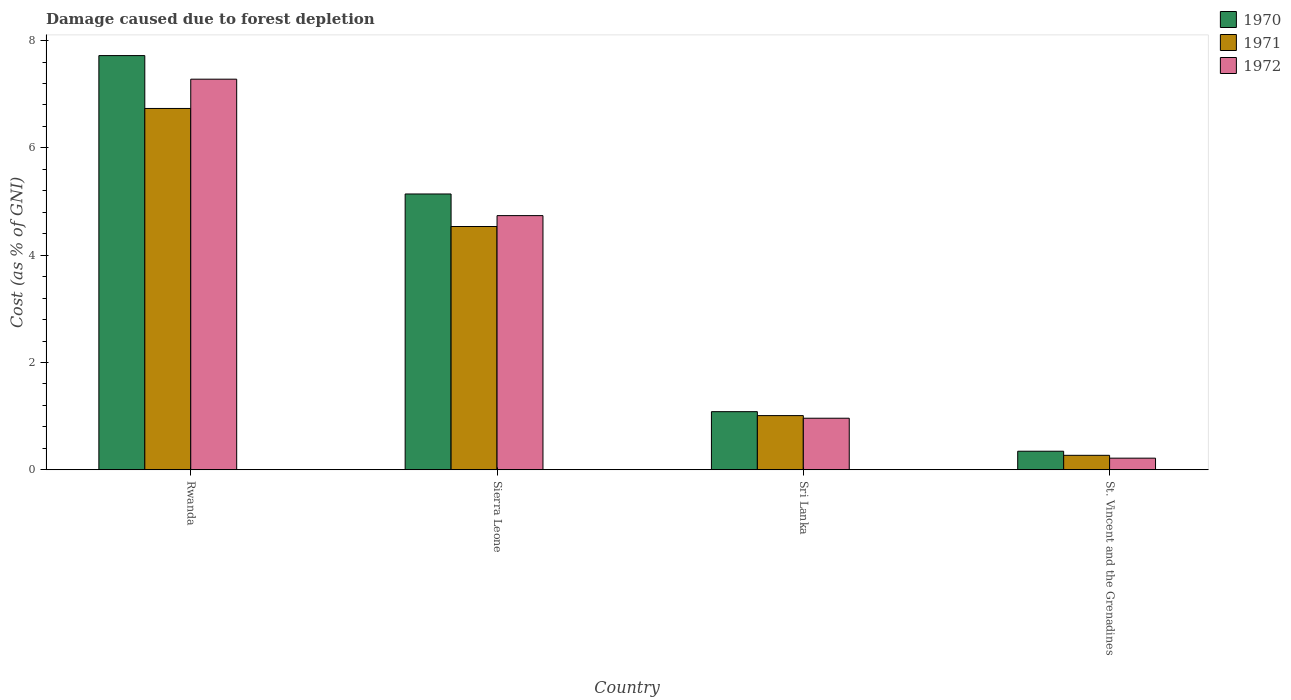How many different coloured bars are there?
Offer a terse response. 3. What is the label of the 4th group of bars from the left?
Your answer should be compact. St. Vincent and the Grenadines. In how many cases, is the number of bars for a given country not equal to the number of legend labels?
Offer a very short reply. 0. What is the cost of damage caused due to forest depletion in 1971 in Sierra Leone?
Make the answer very short. 4.53. Across all countries, what is the maximum cost of damage caused due to forest depletion in 1970?
Give a very brief answer. 7.72. Across all countries, what is the minimum cost of damage caused due to forest depletion in 1971?
Give a very brief answer. 0.27. In which country was the cost of damage caused due to forest depletion in 1972 maximum?
Your response must be concise. Rwanda. In which country was the cost of damage caused due to forest depletion in 1972 minimum?
Offer a terse response. St. Vincent and the Grenadines. What is the total cost of damage caused due to forest depletion in 1970 in the graph?
Offer a terse response. 14.29. What is the difference between the cost of damage caused due to forest depletion in 1971 in Rwanda and that in Sierra Leone?
Provide a short and direct response. 2.2. What is the difference between the cost of damage caused due to forest depletion in 1972 in Sierra Leone and the cost of damage caused due to forest depletion in 1970 in Sri Lanka?
Provide a succinct answer. 3.65. What is the average cost of damage caused due to forest depletion in 1972 per country?
Your answer should be compact. 3.3. What is the difference between the cost of damage caused due to forest depletion of/in 1970 and cost of damage caused due to forest depletion of/in 1972 in Rwanda?
Your response must be concise. 0.44. In how many countries, is the cost of damage caused due to forest depletion in 1971 greater than 2.4 %?
Your answer should be compact. 2. What is the ratio of the cost of damage caused due to forest depletion in 1972 in Rwanda to that in St. Vincent and the Grenadines?
Offer a very short reply. 33.57. Is the cost of damage caused due to forest depletion in 1972 in Rwanda less than that in Sri Lanka?
Your answer should be compact. No. What is the difference between the highest and the second highest cost of damage caused due to forest depletion in 1972?
Keep it short and to the point. -3.78. What is the difference between the highest and the lowest cost of damage caused due to forest depletion in 1972?
Keep it short and to the point. 7.06. What does the 2nd bar from the left in Sri Lanka represents?
Provide a succinct answer. 1971. How many bars are there?
Your answer should be compact. 12. How many countries are there in the graph?
Offer a terse response. 4. What is the difference between two consecutive major ticks on the Y-axis?
Keep it short and to the point. 2. Are the values on the major ticks of Y-axis written in scientific E-notation?
Keep it short and to the point. No. Does the graph contain any zero values?
Make the answer very short. No. Where does the legend appear in the graph?
Keep it short and to the point. Top right. What is the title of the graph?
Keep it short and to the point. Damage caused due to forest depletion. What is the label or title of the Y-axis?
Your response must be concise. Cost (as % of GNI). What is the Cost (as % of GNI) of 1970 in Rwanda?
Your answer should be compact. 7.72. What is the Cost (as % of GNI) of 1971 in Rwanda?
Provide a succinct answer. 6.73. What is the Cost (as % of GNI) of 1972 in Rwanda?
Offer a terse response. 7.28. What is the Cost (as % of GNI) of 1970 in Sierra Leone?
Make the answer very short. 5.14. What is the Cost (as % of GNI) of 1971 in Sierra Leone?
Offer a very short reply. 4.53. What is the Cost (as % of GNI) of 1972 in Sierra Leone?
Your answer should be compact. 4.74. What is the Cost (as % of GNI) of 1970 in Sri Lanka?
Offer a very short reply. 1.08. What is the Cost (as % of GNI) in 1971 in Sri Lanka?
Keep it short and to the point. 1.01. What is the Cost (as % of GNI) in 1972 in Sri Lanka?
Your answer should be compact. 0.96. What is the Cost (as % of GNI) in 1970 in St. Vincent and the Grenadines?
Keep it short and to the point. 0.35. What is the Cost (as % of GNI) in 1971 in St. Vincent and the Grenadines?
Provide a short and direct response. 0.27. What is the Cost (as % of GNI) of 1972 in St. Vincent and the Grenadines?
Keep it short and to the point. 0.22. Across all countries, what is the maximum Cost (as % of GNI) in 1970?
Offer a terse response. 7.72. Across all countries, what is the maximum Cost (as % of GNI) of 1971?
Your answer should be very brief. 6.73. Across all countries, what is the maximum Cost (as % of GNI) in 1972?
Give a very brief answer. 7.28. Across all countries, what is the minimum Cost (as % of GNI) in 1970?
Make the answer very short. 0.35. Across all countries, what is the minimum Cost (as % of GNI) of 1971?
Make the answer very short. 0.27. Across all countries, what is the minimum Cost (as % of GNI) in 1972?
Give a very brief answer. 0.22. What is the total Cost (as % of GNI) in 1970 in the graph?
Provide a succinct answer. 14.29. What is the total Cost (as % of GNI) of 1971 in the graph?
Give a very brief answer. 12.55. What is the total Cost (as % of GNI) of 1972 in the graph?
Give a very brief answer. 13.2. What is the difference between the Cost (as % of GNI) of 1970 in Rwanda and that in Sierra Leone?
Ensure brevity in your answer.  2.58. What is the difference between the Cost (as % of GNI) in 1971 in Rwanda and that in Sierra Leone?
Ensure brevity in your answer.  2.2. What is the difference between the Cost (as % of GNI) in 1972 in Rwanda and that in Sierra Leone?
Your response must be concise. 2.54. What is the difference between the Cost (as % of GNI) of 1970 in Rwanda and that in Sri Lanka?
Your response must be concise. 6.64. What is the difference between the Cost (as % of GNI) in 1971 in Rwanda and that in Sri Lanka?
Give a very brief answer. 5.72. What is the difference between the Cost (as % of GNI) of 1972 in Rwanda and that in Sri Lanka?
Provide a succinct answer. 6.32. What is the difference between the Cost (as % of GNI) in 1970 in Rwanda and that in St. Vincent and the Grenadines?
Ensure brevity in your answer.  7.37. What is the difference between the Cost (as % of GNI) in 1971 in Rwanda and that in St. Vincent and the Grenadines?
Provide a succinct answer. 6.46. What is the difference between the Cost (as % of GNI) of 1972 in Rwanda and that in St. Vincent and the Grenadines?
Provide a short and direct response. 7.06. What is the difference between the Cost (as % of GNI) of 1970 in Sierra Leone and that in Sri Lanka?
Give a very brief answer. 4.06. What is the difference between the Cost (as % of GNI) of 1971 in Sierra Leone and that in Sri Lanka?
Your answer should be compact. 3.52. What is the difference between the Cost (as % of GNI) in 1972 in Sierra Leone and that in Sri Lanka?
Offer a terse response. 3.78. What is the difference between the Cost (as % of GNI) of 1970 in Sierra Leone and that in St. Vincent and the Grenadines?
Ensure brevity in your answer.  4.79. What is the difference between the Cost (as % of GNI) in 1971 in Sierra Leone and that in St. Vincent and the Grenadines?
Your answer should be compact. 4.26. What is the difference between the Cost (as % of GNI) of 1972 in Sierra Leone and that in St. Vincent and the Grenadines?
Your answer should be very brief. 4.52. What is the difference between the Cost (as % of GNI) of 1970 in Sri Lanka and that in St. Vincent and the Grenadines?
Offer a terse response. 0.74. What is the difference between the Cost (as % of GNI) in 1971 in Sri Lanka and that in St. Vincent and the Grenadines?
Keep it short and to the point. 0.74. What is the difference between the Cost (as % of GNI) in 1972 in Sri Lanka and that in St. Vincent and the Grenadines?
Your response must be concise. 0.74. What is the difference between the Cost (as % of GNI) of 1970 in Rwanda and the Cost (as % of GNI) of 1971 in Sierra Leone?
Keep it short and to the point. 3.19. What is the difference between the Cost (as % of GNI) of 1970 in Rwanda and the Cost (as % of GNI) of 1972 in Sierra Leone?
Provide a short and direct response. 2.98. What is the difference between the Cost (as % of GNI) of 1971 in Rwanda and the Cost (as % of GNI) of 1972 in Sierra Leone?
Make the answer very short. 2. What is the difference between the Cost (as % of GNI) in 1970 in Rwanda and the Cost (as % of GNI) in 1971 in Sri Lanka?
Offer a terse response. 6.71. What is the difference between the Cost (as % of GNI) of 1970 in Rwanda and the Cost (as % of GNI) of 1972 in Sri Lanka?
Your answer should be very brief. 6.76. What is the difference between the Cost (as % of GNI) of 1971 in Rwanda and the Cost (as % of GNI) of 1972 in Sri Lanka?
Your answer should be very brief. 5.77. What is the difference between the Cost (as % of GNI) of 1970 in Rwanda and the Cost (as % of GNI) of 1971 in St. Vincent and the Grenadines?
Make the answer very short. 7.45. What is the difference between the Cost (as % of GNI) of 1970 in Rwanda and the Cost (as % of GNI) of 1972 in St. Vincent and the Grenadines?
Your response must be concise. 7.5. What is the difference between the Cost (as % of GNI) in 1971 in Rwanda and the Cost (as % of GNI) in 1972 in St. Vincent and the Grenadines?
Offer a terse response. 6.52. What is the difference between the Cost (as % of GNI) in 1970 in Sierra Leone and the Cost (as % of GNI) in 1971 in Sri Lanka?
Your response must be concise. 4.13. What is the difference between the Cost (as % of GNI) of 1970 in Sierra Leone and the Cost (as % of GNI) of 1972 in Sri Lanka?
Your answer should be very brief. 4.18. What is the difference between the Cost (as % of GNI) in 1971 in Sierra Leone and the Cost (as % of GNI) in 1972 in Sri Lanka?
Ensure brevity in your answer.  3.57. What is the difference between the Cost (as % of GNI) in 1970 in Sierra Leone and the Cost (as % of GNI) in 1971 in St. Vincent and the Grenadines?
Your response must be concise. 4.87. What is the difference between the Cost (as % of GNI) of 1970 in Sierra Leone and the Cost (as % of GNI) of 1972 in St. Vincent and the Grenadines?
Provide a short and direct response. 4.92. What is the difference between the Cost (as % of GNI) of 1971 in Sierra Leone and the Cost (as % of GNI) of 1972 in St. Vincent and the Grenadines?
Make the answer very short. 4.32. What is the difference between the Cost (as % of GNI) of 1970 in Sri Lanka and the Cost (as % of GNI) of 1971 in St. Vincent and the Grenadines?
Give a very brief answer. 0.81. What is the difference between the Cost (as % of GNI) of 1970 in Sri Lanka and the Cost (as % of GNI) of 1972 in St. Vincent and the Grenadines?
Your answer should be compact. 0.87. What is the difference between the Cost (as % of GNI) in 1971 in Sri Lanka and the Cost (as % of GNI) in 1972 in St. Vincent and the Grenadines?
Keep it short and to the point. 0.79. What is the average Cost (as % of GNI) of 1970 per country?
Your response must be concise. 3.57. What is the average Cost (as % of GNI) of 1971 per country?
Your answer should be very brief. 3.14. What is the average Cost (as % of GNI) in 1972 per country?
Provide a short and direct response. 3.3. What is the difference between the Cost (as % of GNI) of 1970 and Cost (as % of GNI) of 1971 in Rwanda?
Keep it short and to the point. 0.99. What is the difference between the Cost (as % of GNI) in 1970 and Cost (as % of GNI) in 1972 in Rwanda?
Make the answer very short. 0.44. What is the difference between the Cost (as % of GNI) of 1971 and Cost (as % of GNI) of 1972 in Rwanda?
Ensure brevity in your answer.  -0.55. What is the difference between the Cost (as % of GNI) in 1970 and Cost (as % of GNI) in 1971 in Sierra Leone?
Offer a very short reply. 0.61. What is the difference between the Cost (as % of GNI) of 1970 and Cost (as % of GNI) of 1972 in Sierra Leone?
Ensure brevity in your answer.  0.4. What is the difference between the Cost (as % of GNI) in 1971 and Cost (as % of GNI) in 1972 in Sierra Leone?
Your response must be concise. -0.2. What is the difference between the Cost (as % of GNI) in 1970 and Cost (as % of GNI) in 1971 in Sri Lanka?
Make the answer very short. 0.07. What is the difference between the Cost (as % of GNI) in 1970 and Cost (as % of GNI) in 1972 in Sri Lanka?
Keep it short and to the point. 0.12. What is the difference between the Cost (as % of GNI) of 1971 and Cost (as % of GNI) of 1972 in Sri Lanka?
Offer a terse response. 0.05. What is the difference between the Cost (as % of GNI) of 1970 and Cost (as % of GNI) of 1971 in St. Vincent and the Grenadines?
Your response must be concise. 0.08. What is the difference between the Cost (as % of GNI) in 1970 and Cost (as % of GNI) in 1972 in St. Vincent and the Grenadines?
Your response must be concise. 0.13. What is the difference between the Cost (as % of GNI) in 1971 and Cost (as % of GNI) in 1972 in St. Vincent and the Grenadines?
Ensure brevity in your answer.  0.05. What is the ratio of the Cost (as % of GNI) in 1970 in Rwanda to that in Sierra Leone?
Provide a short and direct response. 1.5. What is the ratio of the Cost (as % of GNI) of 1971 in Rwanda to that in Sierra Leone?
Provide a short and direct response. 1.49. What is the ratio of the Cost (as % of GNI) in 1972 in Rwanda to that in Sierra Leone?
Make the answer very short. 1.54. What is the ratio of the Cost (as % of GNI) in 1970 in Rwanda to that in Sri Lanka?
Provide a succinct answer. 7.12. What is the ratio of the Cost (as % of GNI) of 1971 in Rwanda to that in Sri Lanka?
Your answer should be very brief. 6.67. What is the ratio of the Cost (as % of GNI) of 1972 in Rwanda to that in Sri Lanka?
Offer a very short reply. 7.57. What is the ratio of the Cost (as % of GNI) in 1970 in Rwanda to that in St. Vincent and the Grenadines?
Offer a very short reply. 22.29. What is the ratio of the Cost (as % of GNI) of 1971 in Rwanda to that in St. Vincent and the Grenadines?
Your answer should be compact. 24.94. What is the ratio of the Cost (as % of GNI) of 1972 in Rwanda to that in St. Vincent and the Grenadines?
Keep it short and to the point. 33.57. What is the ratio of the Cost (as % of GNI) of 1970 in Sierra Leone to that in Sri Lanka?
Keep it short and to the point. 4.74. What is the ratio of the Cost (as % of GNI) in 1971 in Sierra Leone to that in Sri Lanka?
Make the answer very short. 4.49. What is the ratio of the Cost (as % of GNI) in 1972 in Sierra Leone to that in Sri Lanka?
Your response must be concise. 4.93. What is the ratio of the Cost (as % of GNI) of 1970 in Sierra Leone to that in St. Vincent and the Grenadines?
Give a very brief answer. 14.84. What is the ratio of the Cost (as % of GNI) in 1971 in Sierra Leone to that in St. Vincent and the Grenadines?
Ensure brevity in your answer.  16.79. What is the ratio of the Cost (as % of GNI) of 1972 in Sierra Leone to that in St. Vincent and the Grenadines?
Offer a terse response. 21.84. What is the ratio of the Cost (as % of GNI) in 1970 in Sri Lanka to that in St. Vincent and the Grenadines?
Your answer should be very brief. 3.13. What is the ratio of the Cost (as % of GNI) in 1971 in Sri Lanka to that in St. Vincent and the Grenadines?
Give a very brief answer. 3.74. What is the ratio of the Cost (as % of GNI) of 1972 in Sri Lanka to that in St. Vincent and the Grenadines?
Your answer should be very brief. 4.43. What is the difference between the highest and the second highest Cost (as % of GNI) of 1970?
Provide a succinct answer. 2.58. What is the difference between the highest and the second highest Cost (as % of GNI) in 1971?
Your answer should be very brief. 2.2. What is the difference between the highest and the second highest Cost (as % of GNI) of 1972?
Ensure brevity in your answer.  2.54. What is the difference between the highest and the lowest Cost (as % of GNI) in 1970?
Your answer should be compact. 7.37. What is the difference between the highest and the lowest Cost (as % of GNI) of 1971?
Your response must be concise. 6.46. What is the difference between the highest and the lowest Cost (as % of GNI) in 1972?
Your response must be concise. 7.06. 